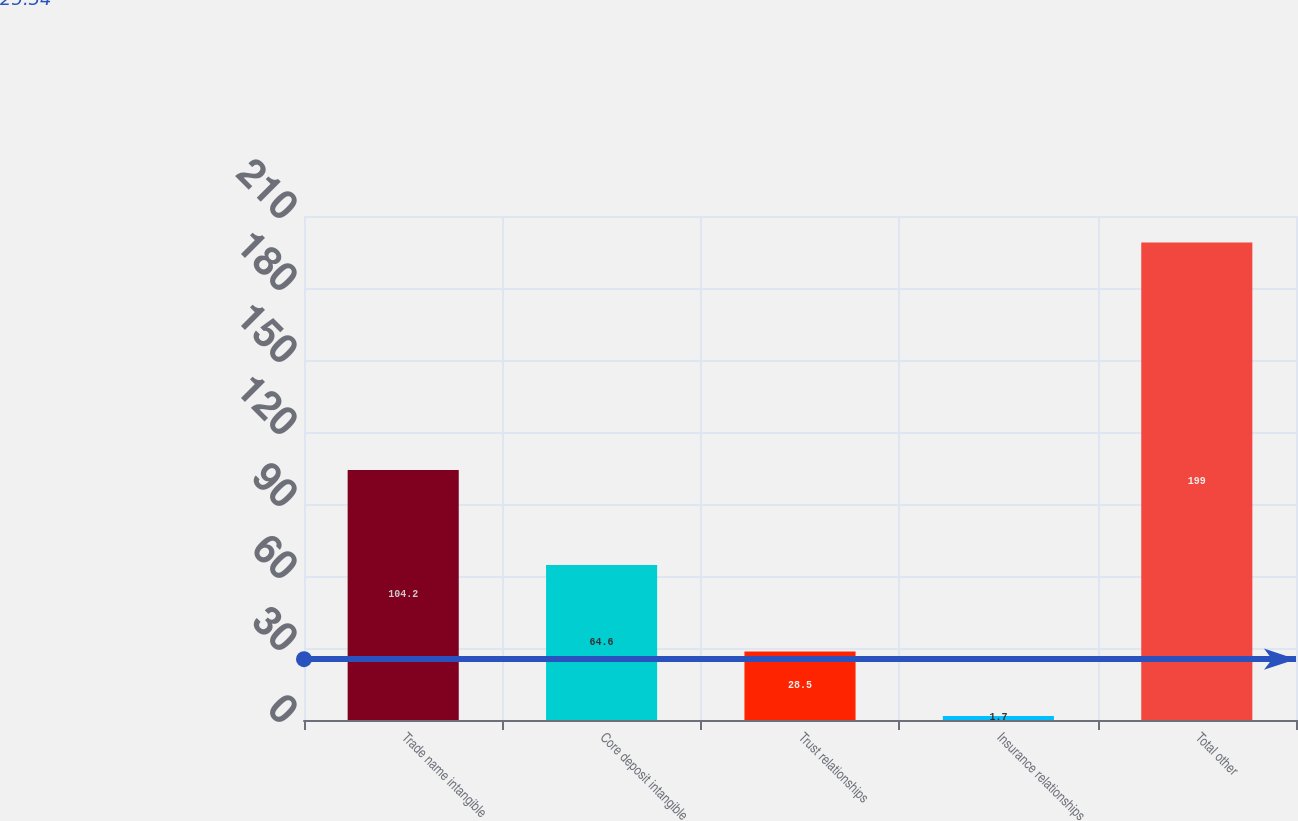<chart> <loc_0><loc_0><loc_500><loc_500><bar_chart><fcel>Trade name intangible<fcel>Core deposit intangible<fcel>Trust relationships<fcel>Insurance relationships<fcel>Total other<nl><fcel>104.2<fcel>64.6<fcel>28.5<fcel>1.7<fcel>199<nl></chart> 